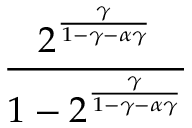Convert formula to latex. <formula><loc_0><loc_0><loc_500><loc_500>\frac { 2 ^ { \frac { \gamma } { 1 - \gamma - \alpha \gamma } } } { 1 - 2 ^ { \frac { \gamma } { 1 - \gamma - \alpha \gamma } } }</formula> 